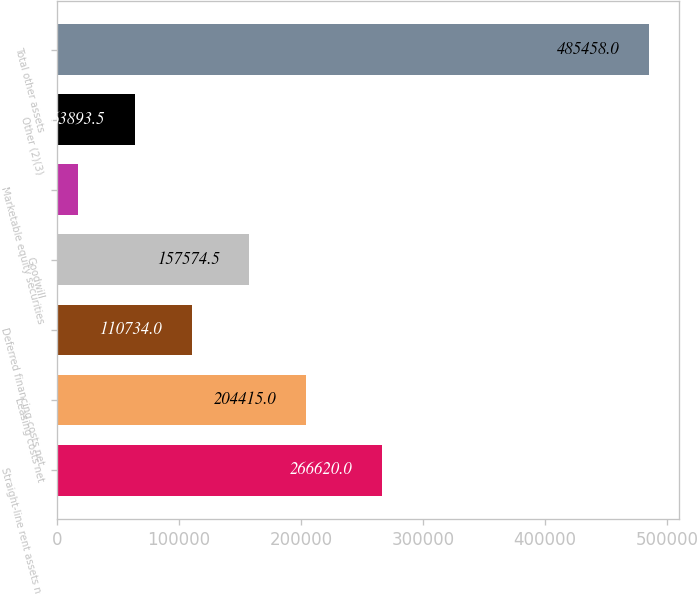Convert chart to OTSL. <chart><loc_0><loc_0><loc_500><loc_500><bar_chart><fcel>Straight-line rent assets net<fcel>Leasing costs net<fcel>Deferred financing costs net<fcel>Goodwill<fcel>Marketable equity securities<fcel>Other (2)(3)<fcel>Total other assets<nl><fcel>266620<fcel>204415<fcel>110734<fcel>157574<fcel>17053<fcel>63893.5<fcel>485458<nl></chart> 